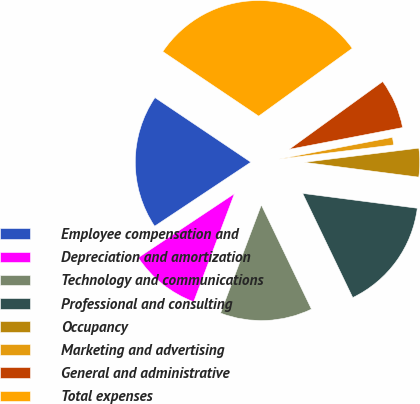Convert chart. <chart><loc_0><loc_0><loc_500><loc_500><pie_chart><fcel>Employee compensation and<fcel>Depreciation and amortization<fcel>Technology and communications<fcel>Professional and consulting<fcel>Occupancy<fcel>Marketing and advertising<fcel>General and administrative<fcel>Total expenses<nl><fcel>18.78%<fcel>9.92%<fcel>12.87%<fcel>15.82%<fcel>4.01%<fcel>1.06%<fcel>6.96%<fcel>30.59%<nl></chart> 